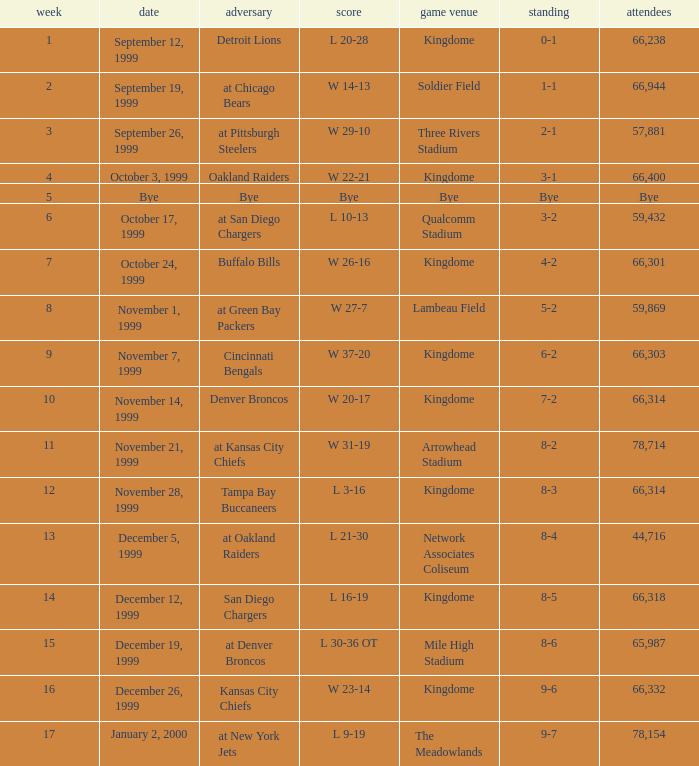What was the result of the game that was played on week 15? L 30-36 OT. 